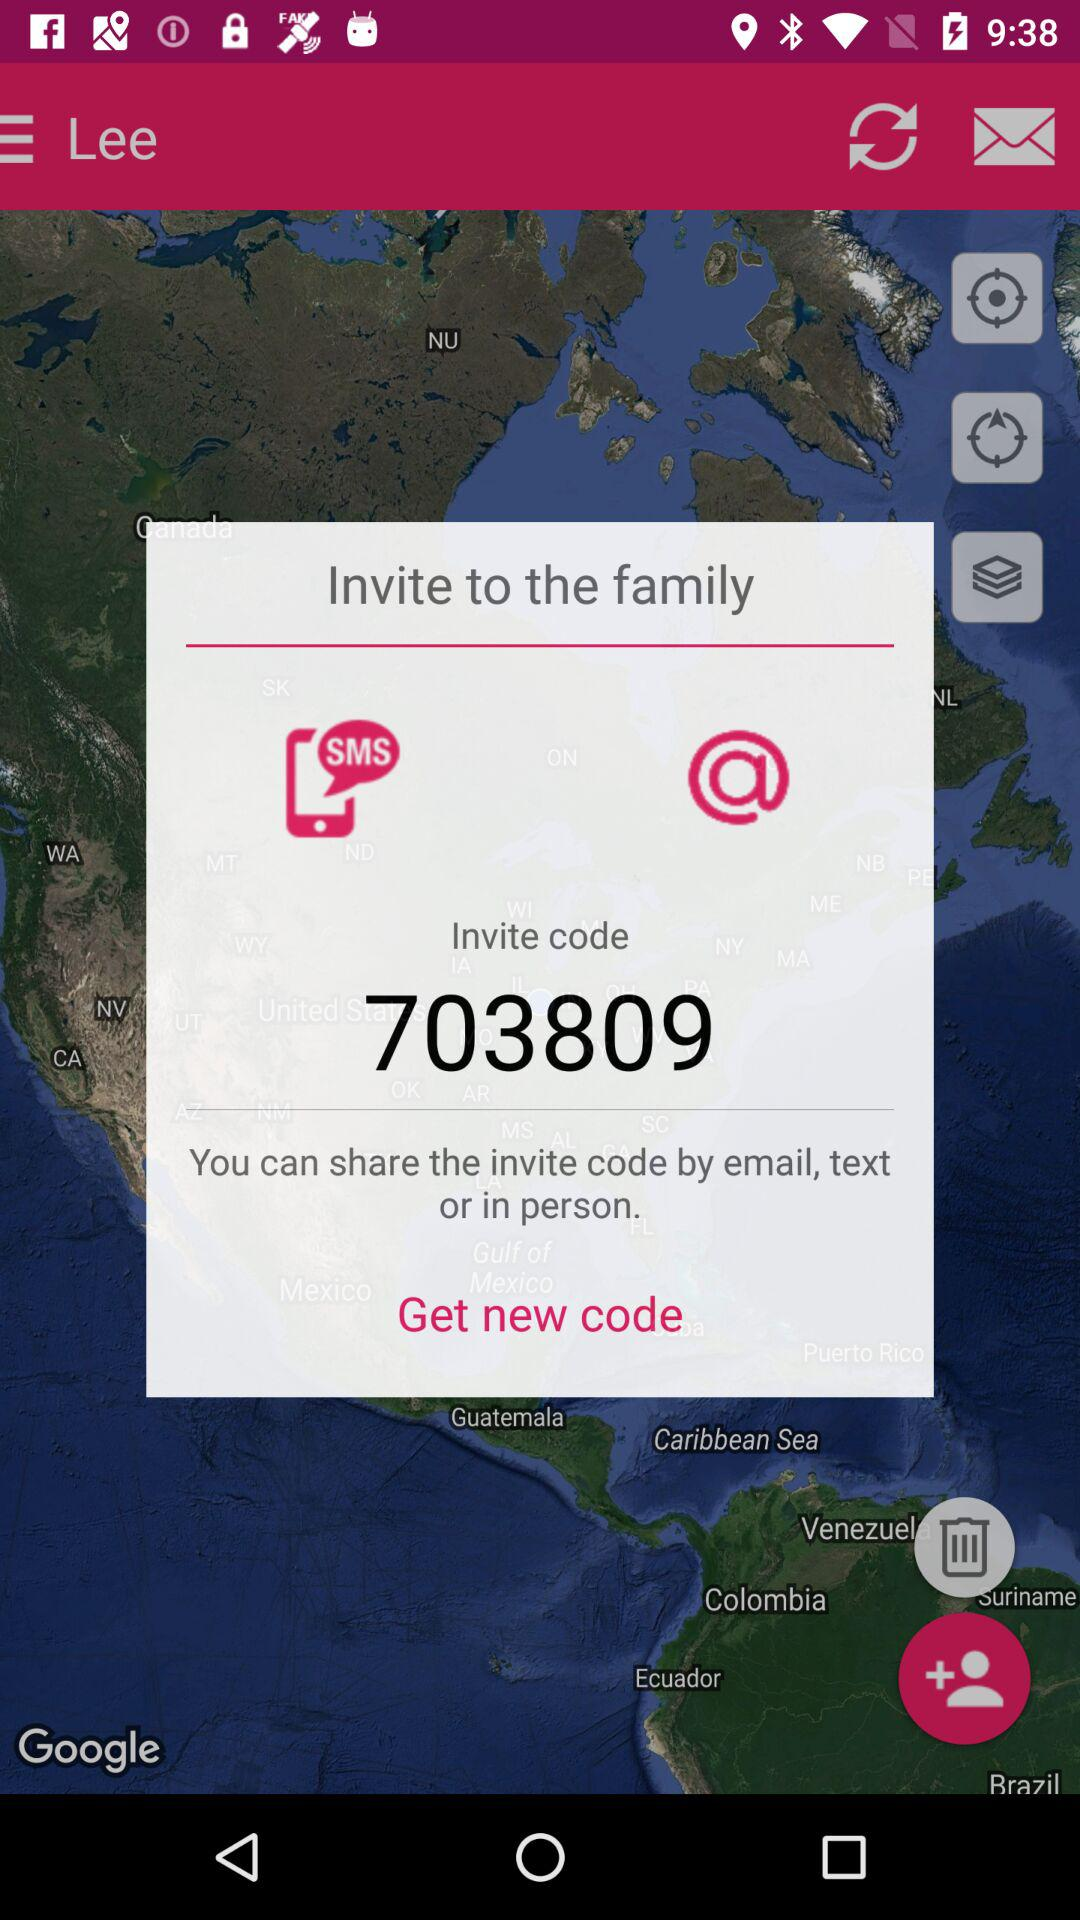How can we share the invite code? You can share the invite code by email, text or in person. 